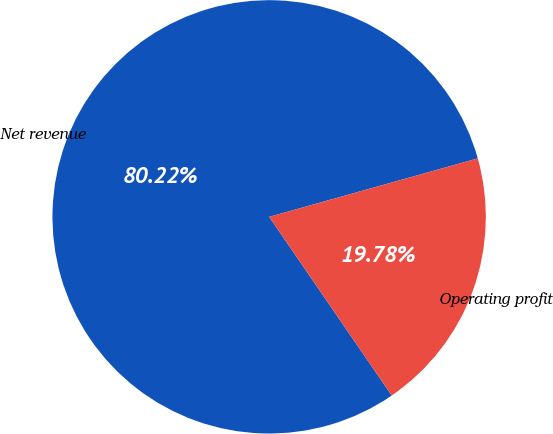Convert chart. <chart><loc_0><loc_0><loc_500><loc_500><pie_chart><fcel>Net revenue<fcel>Operating profit<nl><fcel>80.22%<fcel>19.78%<nl></chart> 